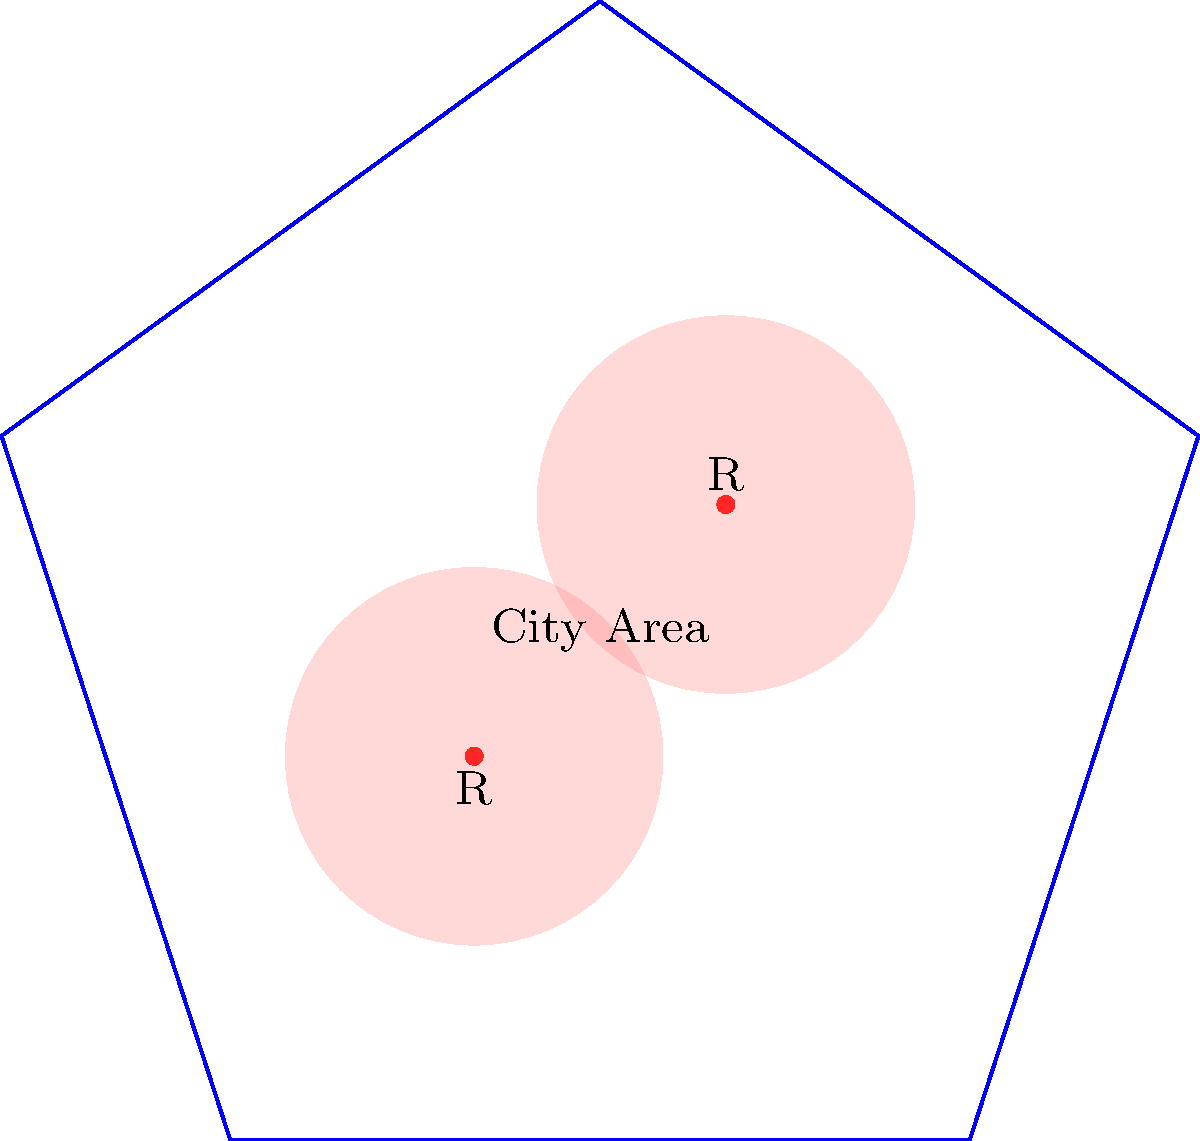In a pentagonal city area, two restaurants (R) are located as shown. If a buffer zone of 0.3 units is created around each restaurant where food trucks are not allowed to operate, what percentage of the city area remains available for food truck operations? Assume the side length of the pentagon is 1 unit. To solve this problem, we'll follow these steps:

1. Calculate the total area of the pentagonal city:
   Area of a regular pentagon = $\frac{5a^2}{4}\tan(54°)$, where $a$ is the side length.
   $A_{city} = \frac{5(1^2)}{4}\tan(54°) \approx 1.72$ square units

2. Calculate the area of each buffer zone:
   Area of a circle = $\pi r^2$
   $A_{buffer} = \pi (0.3^2) \approx 0.2827$ square units

3. Calculate the total buffer zone area:
   $A_{total buffer} = 2 \times 0.2827 = 0.5654$ square units

4. However, the buffer zones overlap. We need to subtract this overlap to avoid double-counting:
   Approximate overlap area $\approx 0.05$ square units (estimated from the diagram)
   $A_{actual buffer} = 0.5654 - 0.05 = 0.5154$ square units

5. Calculate the remaining area for food trucks:
   $A_{remaining} = A_{city} - A_{actual buffer} = 1.72 - 0.5154 = 1.2046$ square units

6. Calculate the percentage of area available for food trucks:
   $Percentage = \frac{A_{remaining}}{A_{city}} \times 100\% = \frac{1.2046}{1.72} \times 100\% \approx 70.03\%$
Answer: 70.03% 